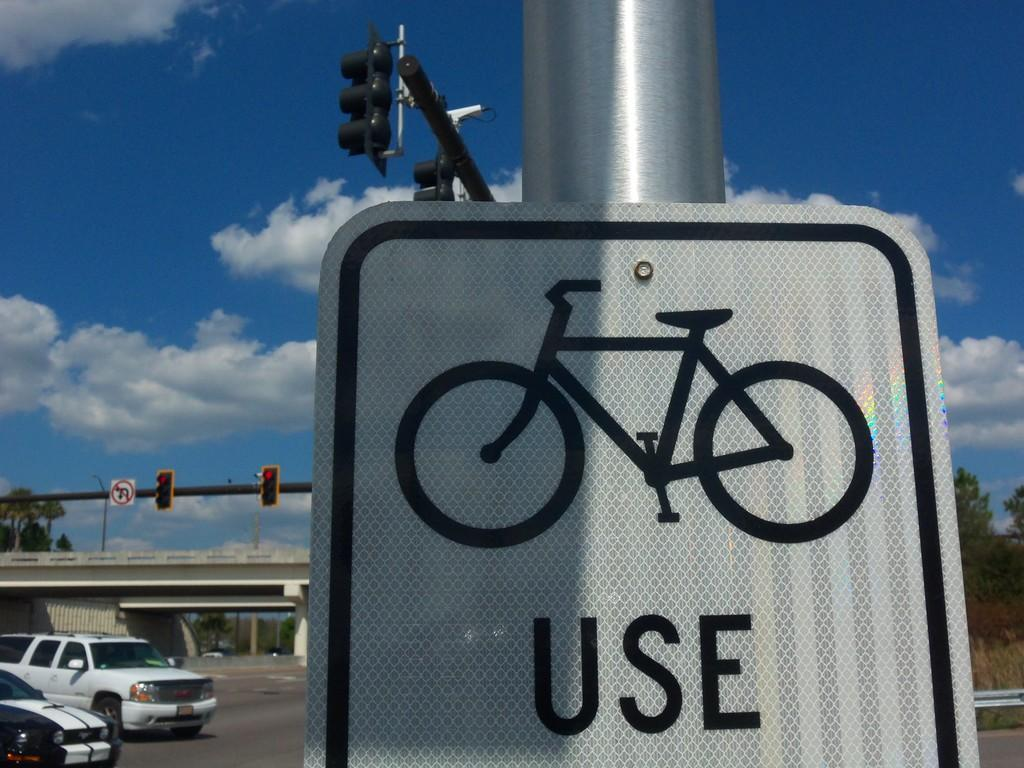What is the main object in the foreground of the image? There is a board on a pole in the foreground of the image. What can be seen in the background of the image? Vehicles on the road, a bridge, trees, traffic signal poles, a sign board pole, and grass are present in the background. What is the condition of the sky in the image? Clouds are visible in the sky. What shape is the hammer taking in the image? There is no hammer present in the image. What is the mind of the person in the image thinking about? There is no person present in the image, so it is impossible to determine what they might be thinking about. 